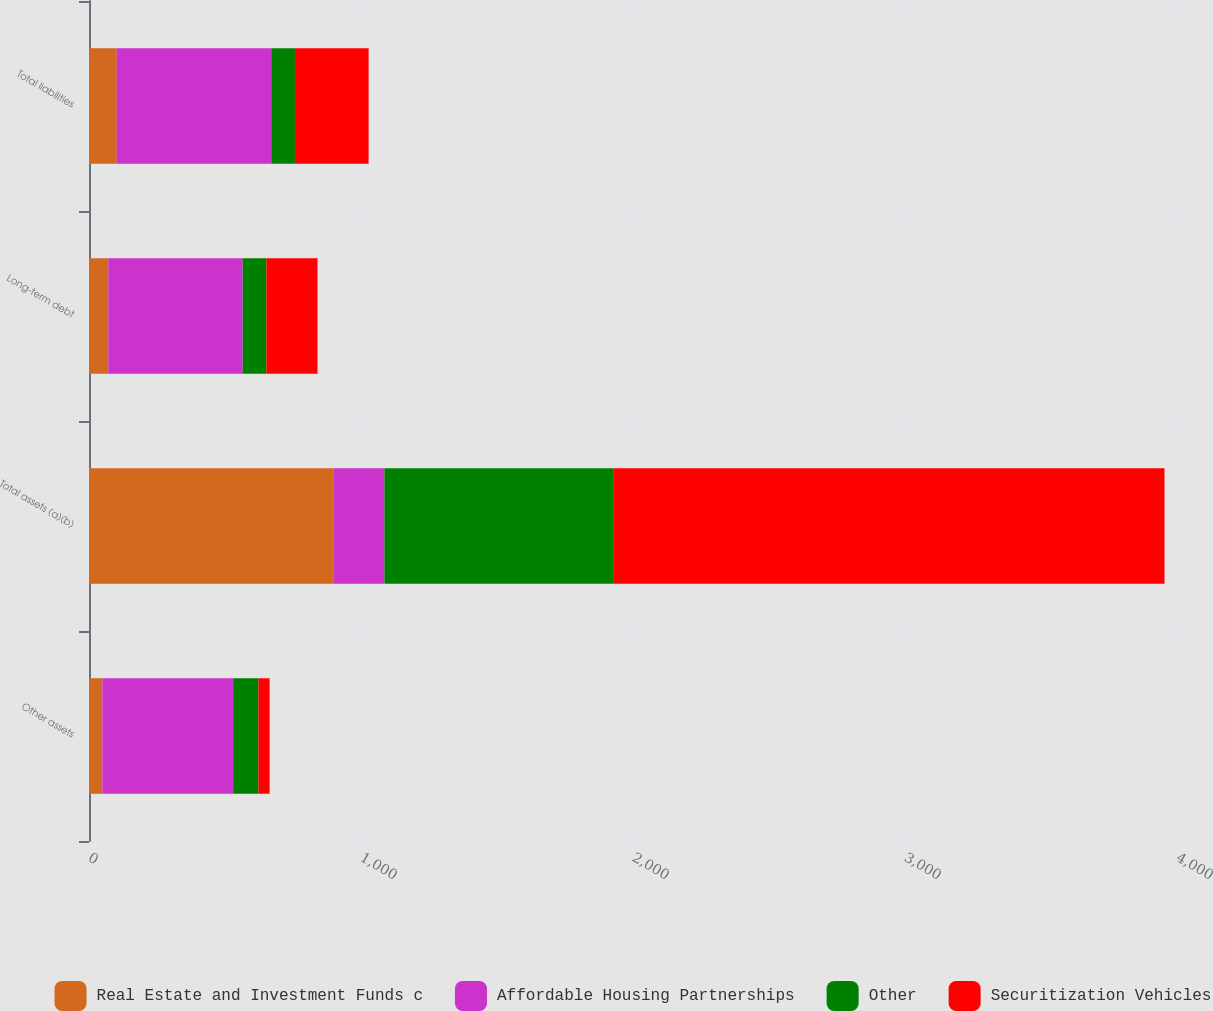Convert chart to OTSL. <chart><loc_0><loc_0><loc_500><loc_500><stacked_bar_chart><ecel><fcel>Other assets<fcel>Total assets (a)(b)<fcel>Long-term debt<fcel>Total liabilities<nl><fcel>Real Estate and Investment Funds c<fcel>49<fcel>898<fcel>71<fcel>102<nl><fcel>Affordable Housing Partnerships<fcel>481<fcel>188<fcel>494<fcel>568<nl><fcel>Other<fcel>93<fcel>841<fcel>87<fcel>87<nl><fcel>Securitization Vehicles<fcel>41<fcel>2027<fcel>188<fcel>271<nl></chart> 